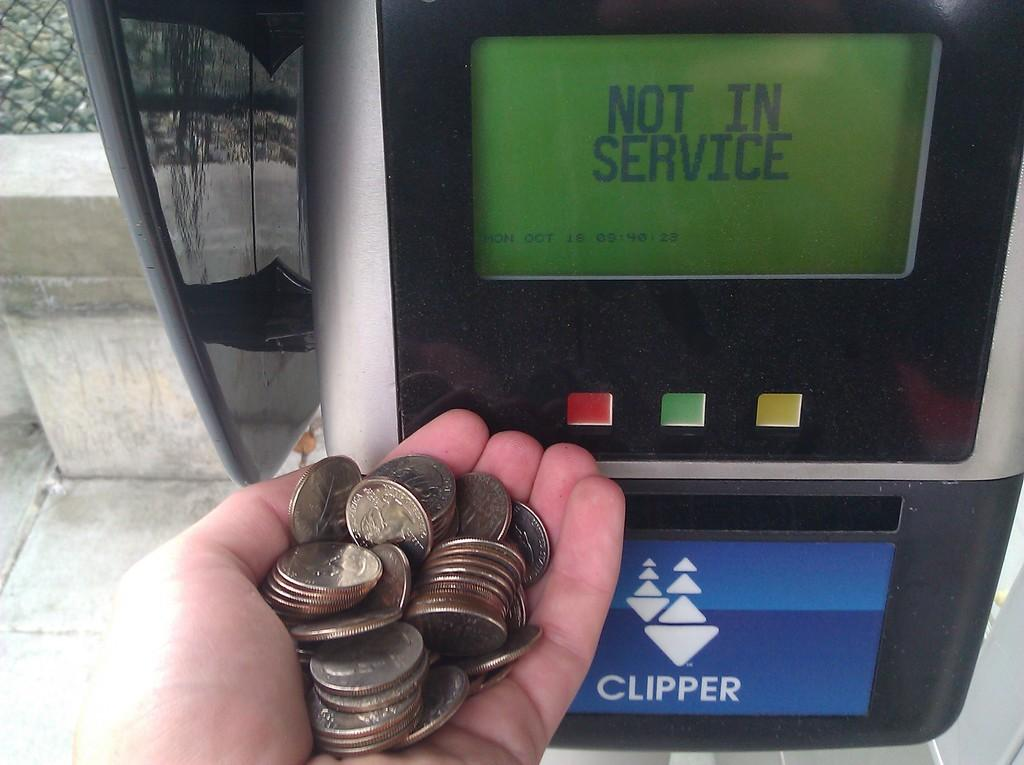<image>
Provide a brief description of the given image. Someone holds a handful of coins in front of a machine that is not in service. 